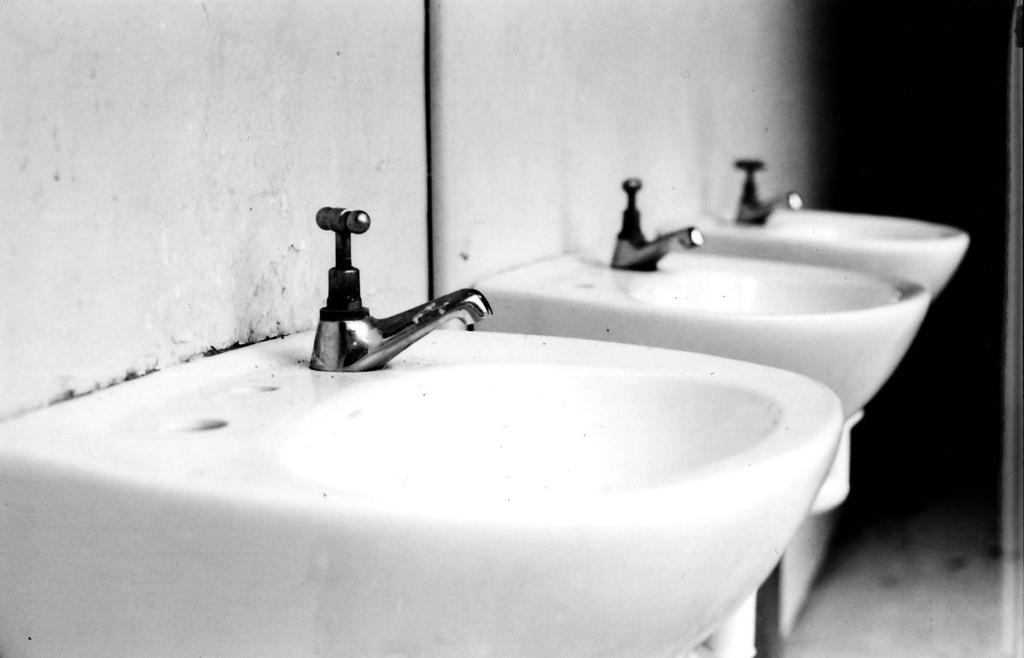Can you describe this image briefly? This is a black and white picture, in this image we can see some sinks attached to the wall. 